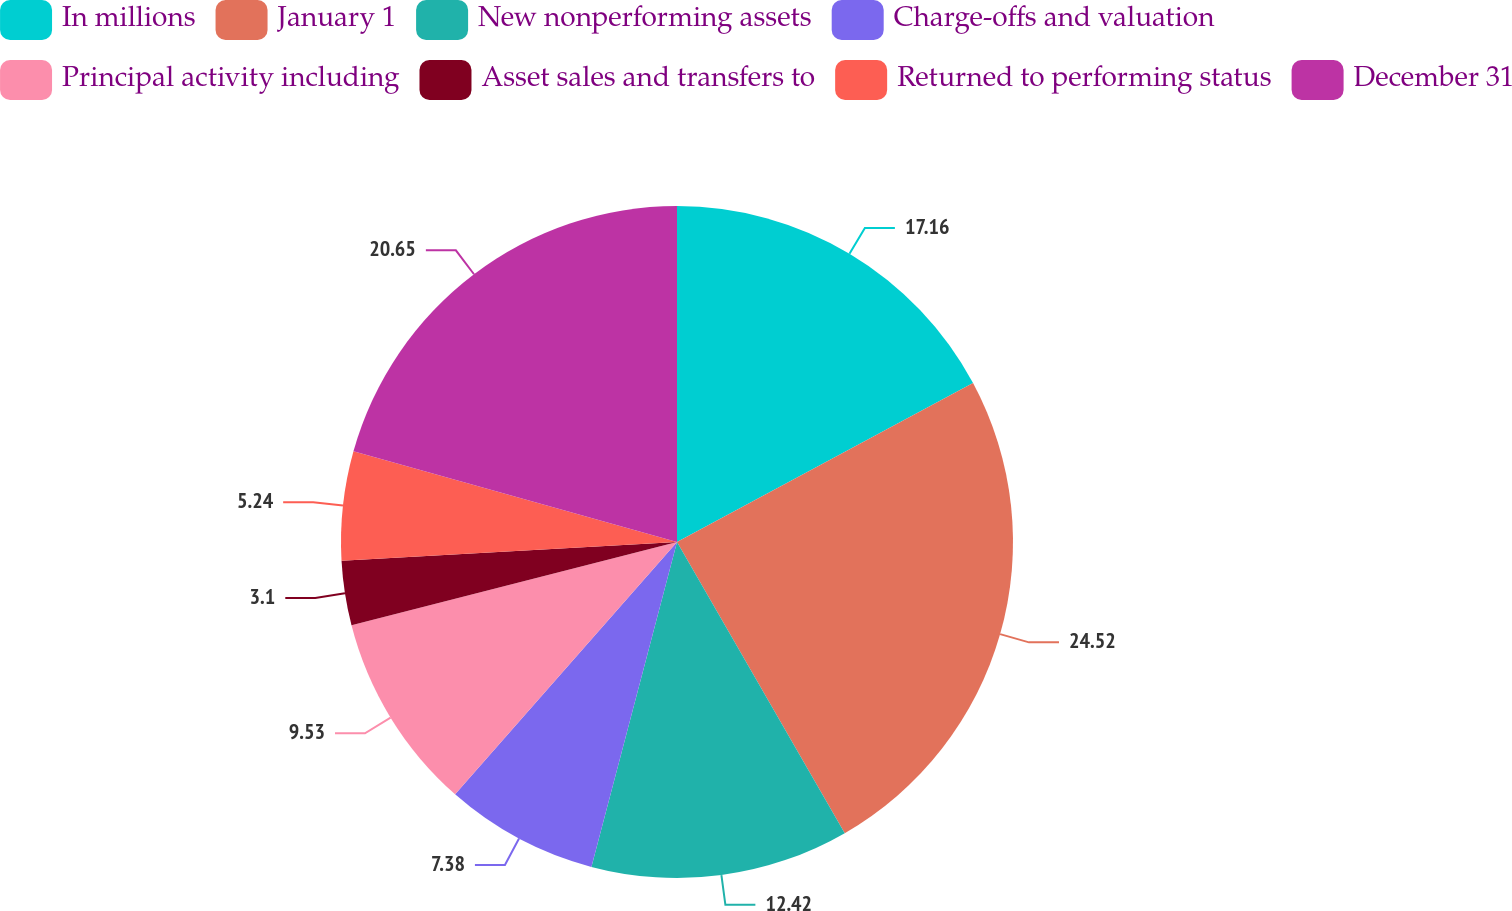Convert chart. <chart><loc_0><loc_0><loc_500><loc_500><pie_chart><fcel>In millions<fcel>January 1<fcel>New nonperforming assets<fcel>Charge-offs and valuation<fcel>Principal activity including<fcel>Asset sales and transfers to<fcel>Returned to performing status<fcel>December 31<nl><fcel>17.16%<fcel>24.52%<fcel>12.42%<fcel>7.38%<fcel>9.53%<fcel>3.1%<fcel>5.24%<fcel>20.65%<nl></chart> 